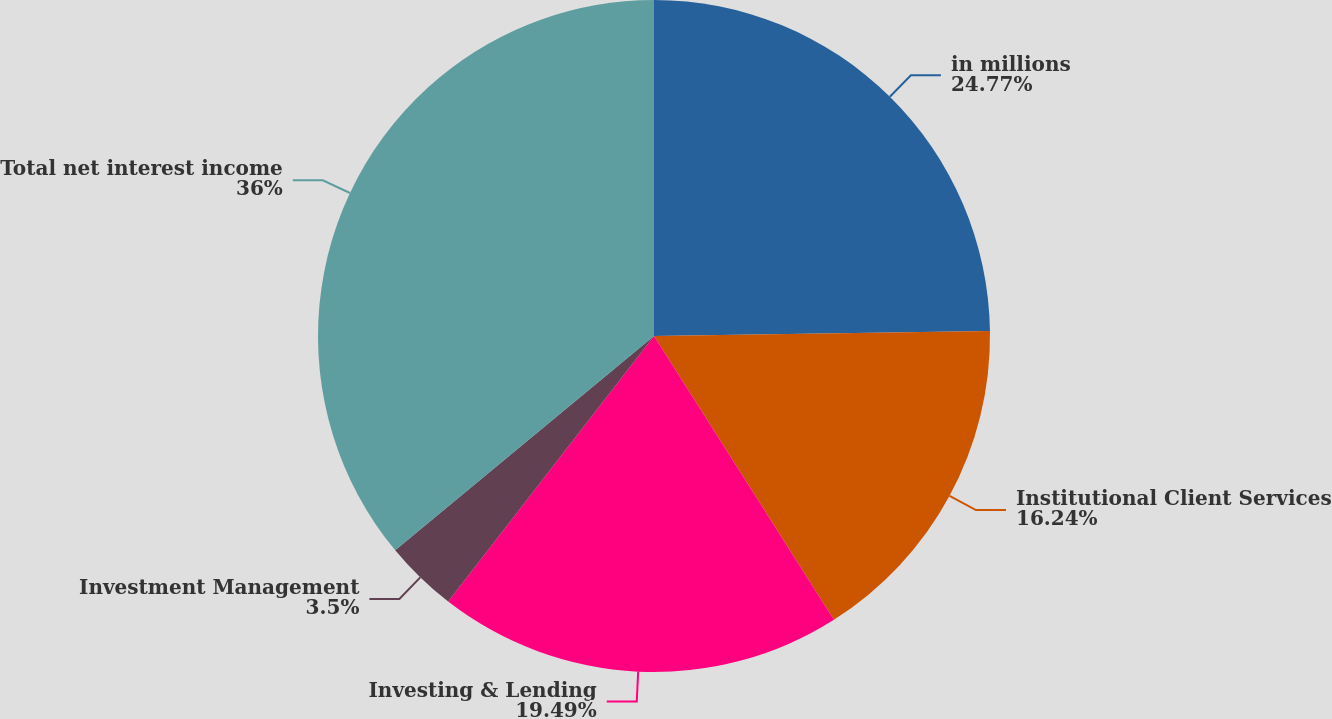Convert chart to OTSL. <chart><loc_0><loc_0><loc_500><loc_500><pie_chart><fcel>in millions<fcel>Institutional Client Services<fcel>Investing & Lending<fcel>Investment Management<fcel>Total net interest income<nl><fcel>24.77%<fcel>16.24%<fcel>19.49%<fcel>3.5%<fcel>36.01%<nl></chart> 